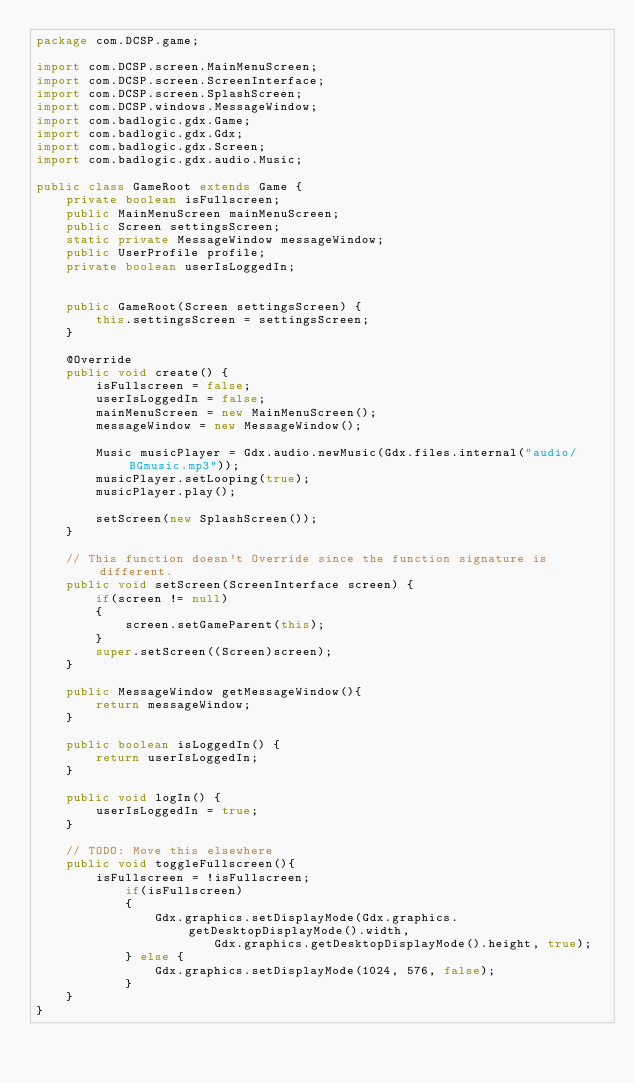<code> <loc_0><loc_0><loc_500><loc_500><_Java_>package com.DCSP.game;                                      

import com.DCSP.screen.MainMenuScreen;
import com.DCSP.screen.ScreenInterface;
import com.DCSP.screen.SplashScreen;
import com.DCSP.windows.MessageWindow;
import com.badlogic.gdx.Game;
import com.badlogic.gdx.Gdx;
import com.badlogic.gdx.Screen;
import com.badlogic.gdx.audio.Music;

public class GameRoot extends Game {
    private boolean isFullscreen;
    public MainMenuScreen mainMenuScreen;
    public Screen settingsScreen;
    static private MessageWindow messageWindow;
    public UserProfile profile;
    private boolean userIsLoggedIn;
    
    
    public GameRoot(Screen settingsScreen) {
        this.settingsScreen = settingsScreen;
    }
    
    @Override
    public void create() {
        isFullscreen = false;
        userIsLoggedIn = false;
        mainMenuScreen = new MainMenuScreen();
        messageWindow = new MessageWindow();
        
        Music musicPlayer = Gdx.audio.newMusic(Gdx.files.internal("audio/BGmusic.mp3"));
        musicPlayer.setLooping(true);
        musicPlayer.play();
        
        setScreen(new SplashScreen());
    }

    // This function doesn't Override since the function signature is different.
    public void setScreen(ScreenInterface screen) {
        if(screen != null)
        {
            screen.setGameParent(this);
        }
        super.setScreen((Screen)screen);
    }
    
    public MessageWindow getMessageWindow(){
        return messageWindow;
    }
        
    public boolean isLoggedIn() {
        return userIsLoggedIn;
    }
    
    public void logIn() {
        userIsLoggedIn = true;
    }
    
    // TODO: Move this elsewhere
    public void toggleFullscreen(){
        isFullscreen = !isFullscreen;
            if(isFullscreen)
            {
                Gdx.graphics.setDisplayMode(Gdx.graphics.getDesktopDisplayMode().width, 
                        Gdx.graphics.getDesktopDisplayMode().height, true);
            } else {
                Gdx.graphics.setDisplayMode(1024, 576, false);
            }
    }
}
</code> 